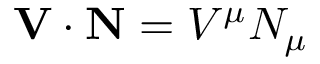<formula> <loc_0><loc_0><loc_500><loc_500>V \cdot N = V ^ { \mu } N _ { \mu }</formula> 